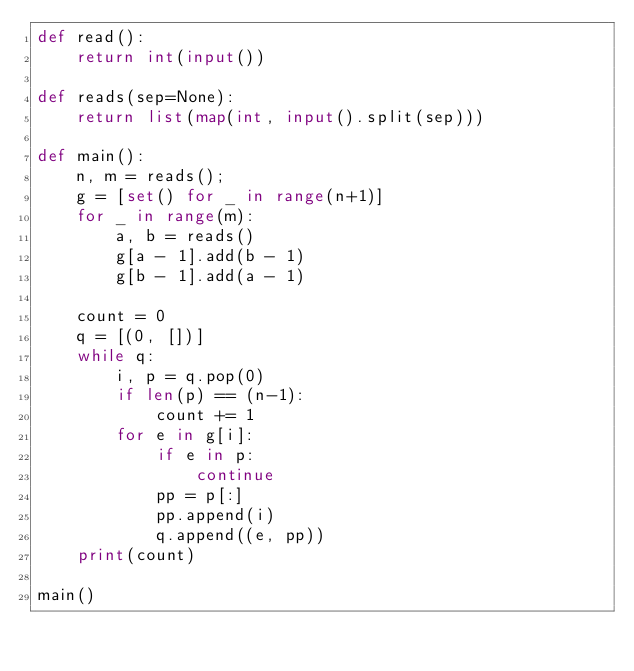<code> <loc_0><loc_0><loc_500><loc_500><_Python_>def read():
    return int(input())

def reads(sep=None):
    return list(map(int, input().split(sep)))

def main():
    n, m = reads();
    g = [set() for _ in range(n+1)]
    for _ in range(m):
        a, b = reads()
        g[a - 1].add(b - 1)
        g[b - 1].add(a - 1)
    
    count = 0
    q = [(0, [])]
    while q:
        i, p = q.pop(0)
        if len(p) == (n-1):
            count += 1
        for e in g[i]:
            if e in p:
                continue
            pp = p[:]
            pp.append(i)
            q.append((e, pp))
    print(count)
 
main()
</code> 